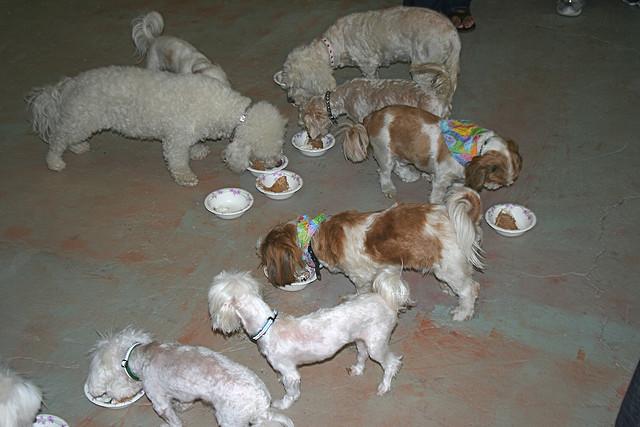Did a human feed these animals?
Give a very brief answer. Yes. How many bowls are empty?
Concise answer only. 1. Do some of these animals need to eat more than others?
Quick response, please. Yes. 